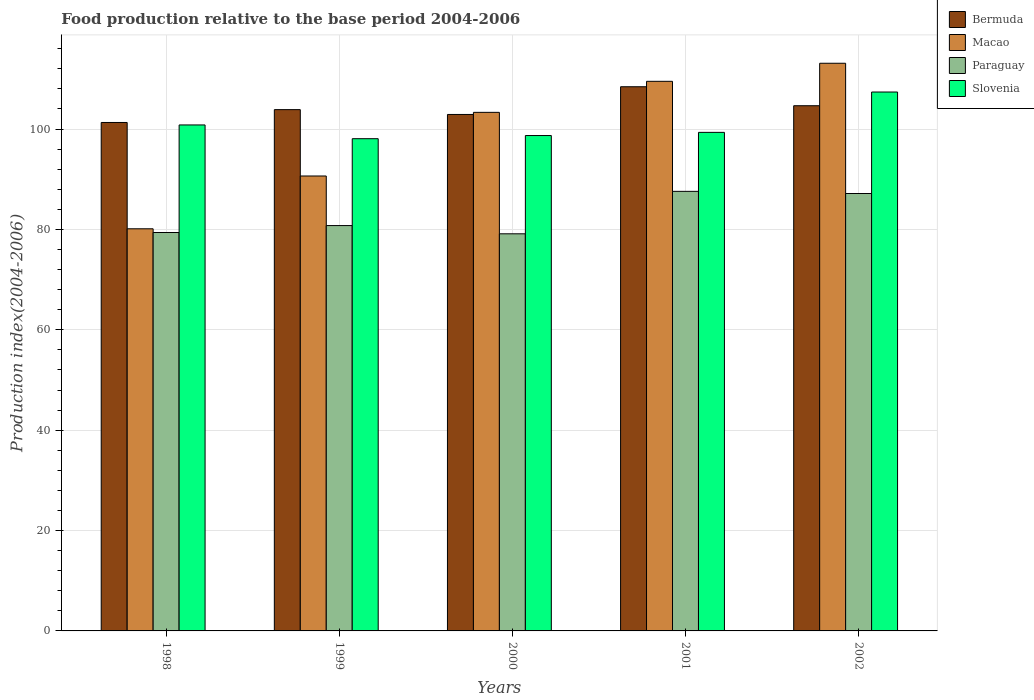How many groups of bars are there?
Offer a terse response. 5. How many bars are there on the 1st tick from the left?
Provide a short and direct response. 4. How many bars are there on the 2nd tick from the right?
Offer a very short reply. 4. What is the label of the 4th group of bars from the left?
Your answer should be very brief. 2001. In how many cases, is the number of bars for a given year not equal to the number of legend labels?
Give a very brief answer. 0. What is the food production index in Paraguay in 1998?
Offer a very short reply. 79.38. Across all years, what is the maximum food production index in Macao?
Your answer should be very brief. 113.1. Across all years, what is the minimum food production index in Bermuda?
Your answer should be compact. 101.3. What is the total food production index in Slovenia in the graph?
Provide a short and direct response. 504.28. What is the difference between the food production index in Macao in 1999 and that in 2000?
Your answer should be very brief. -12.68. What is the difference between the food production index in Slovenia in 2000 and the food production index in Macao in 1999?
Provide a succinct answer. 8.06. What is the average food production index in Paraguay per year?
Offer a very short reply. 82.8. In the year 2000, what is the difference between the food production index in Macao and food production index in Bermuda?
Keep it short and to the point. 0.42. What is the ratio of the food production index in Paraguay in 1998 to that in 2001?
Make the answer very short. 0.91. Is the difference between the food production index in Macao in 1999 and 2001 greater than the difference between the food production index in Bermuda in 1999 and 2001?
Offer a very short reply. No. What is the difference between the highest and the second highest food production index in Paraguay?
Provide a short and direct response. 0.43. What is the difference between the highest and the lowest food production index in Macao?
Your answer should be very brief. 32.98. Is the sum of the food production index in Bermuda in 1998 and 2002 greater than the maximum food production index in Paraguay across all years?
Keep it short and to the point. Yes. Is it the case that in every year, the sum of the food production index in Bermuda and food production index in Paraguay is greater than the sum of food production index in Macao and food production index in Slovenia?
Your answer should be very brief. No. What does the 2nd bar from the left in 2001 represents?
Provide a short and direct response. Macao. What does the 4th bar from the right in 1998 represents?
Provide a succinct answer. Bermuda. Is it the case that in every year, the sum of the food production index in Paraguay and food production index in Bermuda is greater than the food production index in Slovenia?
Make the answer very short. Yes. Are all the bars in the graph horizontal?
Offer a terse response. No. What is the difference between two consecutive major ticks on the Y-axis?
Your answer should be very brief. 20. How many legend labels are there?
Give a very brief answer. 4. What is the title of the graph?
Keep it short and to the point. Food production relative to the base period 2004-2006. What is the label or title of the X-axis?
Keep it short and to the point. Years. What is the label or title of the Y-axis?
Your response must be concise. Production index(2004-2006). What is the Production index(2004-2006) of Bermuda in 1998?
Offer a very short reply. 101.3. What is the Production index(2004-2006) of Macao in 1998?
Make the answer very short. 80.12. What is the Production index(2004-2006) of Paraguay in 1998?
Provide a succinct answer. 79.38. What is the Production index(2004-2006) in Slovenia in 1998?
Give a very brief answer. 100.81. What is the Production index(2004-2006) of Bermuda in 1999?
Provide a succinct answer. 103.86. What is the Production index(2004-2006) of Macao in 1999?
Your response must be concise. 90.64. What is the Production index(2004-2006) in Paraguay in 1999?
Provide a short and direct response. 80.76. What is the Production index(2004-2006) in Slovenia in 1999?
Provide a succinct answer. 98.07. What is the Production index(2004-2006) in Bermuda in 2000?
Keep it short and to the point. 102.9. What is the Production index(2004-2006) in Macao in 2000?
Your answer should be compact. 103.32. What is the Production index(2004-2006) in Paraguay in 2000?
Offer a terse response. 79.12. What is the Production index(2004-2006) of Slovenia in 2000?
Ensure brevity in your answer.  98.7. What is the Production index(2004-2006) of Bermuda in 2001?
Your answer should be very brief. 108.42. What is the Production index(2004-2006) in Macao in 2001?
Keep it short and to the point. 109.5. What is the Production index(2004-2006) of Paraguay in 2001?
Keep it short and to the point. 87.58. What is the Production index(2004-2006) in Slovenia in 2001?
Ensure brevity in your answer.  99.33. What is the Production index(2004-2006) in Bermuda in 2002?
Offer a terse response. 104.64. What is the Production index(2004-2006) in Macao in 2002?
Provide a short and direct response. 113.1. What is the Production index(2004-2006) in Paraguay in 2002?
Keep it short and to the point. 87.15. What is the Production index(2004-2006) in Slovenia in 2002?
Offer a very short reply. 107.37. Across all years, what is the maximum Production index(2004-2006) of Bermuda?
Make the answer very short. 108.42. Across all years, what is the maximum Production index(2004-2006) of Macao?
Your response must be concise. 113.1. Across all years, what is the maximum Production index(2004-2006) in Paraguay?
Ensure brevity in your answer.  87.58. Across all years, what is the maximum Production index(2004-2006) in Slovenia?
Your response must be concise. 107.37. Across all years, what is the minimum Production index(2004-2006) in Bermuda?
Ensure brevity in your answer.  101.3. Across all years, what is the minimum Production index(2004-2006) in Macao?
Offer a very short reply. 80.12. Across all years, what is the minimum Production index(2004-2006) of Paraguay?
Offer a very short reply. 79.12. Across all years, what is the minimum Production index(2004-2006) of Slovenia?
Offer a terse response. 98.07. What is the total Production index(2004-2006) of Bermuda in the graph?
Provide a succinct answer. 521.12. What is the total Production index(2004-2006) of Macao in the graph?
Offer a very short reply. 496.68. What is the total Production index(2004-2006) in Paraguay in the graph?
Give a very brief answer. 413.99. What is the total Production index(2004-2006) of Slovenia in the graph?
Give a very brief answer. 504.28. What is the difference between the Production index(2004-2006) of Bermuda in 1998 and that in 1999?
Your response must be concise. -2.56. What is the difference between the Production index(2004-2006) in Macao in 1998 and that in 1999?
Your response must be concise. -10.52. What is the difference between the Production index(2004-2006) in Paraguay in 1998 and that in 1999?
Keep it short and to the point. -1.38. What is the difference between the Production index(2004-2006) in Slovenia in 1998 and that in 1999?
Keep it short and to the point. 2.74. What is the difference between the Production index(2004-2006) of Macao in 1998 and that in 2000?
Keep it short and to the point. -23.2. What is the difference between the Production index(2004-2006) of Paraguay in 1998 and that in 2000?
Your answer should be very brief. 0.26. What is the difference between the Production index(2004-2006) in Slovenia in 1998 and that in 2000?
Your answer should be compact. 2.11. What is the difference between the Production index(2004-2006) of Bermuda in 1998 and that in 2001?
Make the answer very short. -7.12. What is the difference between the Production index(2004-2006) in Macao in 1998 and that in 2001?
Your answer should be very brief. -29.38. What is the difference between the Production index(2004-2006) in Slovenia in 1998 and that in 2001?
Keep it short and to the point. 1.48. What is the difference between the Production index(2004-2006) in Bermuda in 1998 and that in 2002?
Make the answer very short. -3.34. What is the difference between the Production index(2004-2006) of Macao in 1998 and that in 2002?
Provide a short and direct response. -32.98. What is the difference between the Production index(2004-2006) in Paraguay in 1998 and that in 2002?
Your response must be concise. -7.77. What is the difference between the Production index(2004-2006) of Slovenia in 1998 and that in 2002?
Provide a short and direct response. -6.56. What is the difference between the Production index(2004-2006) in Macao in 1999 and that in 2000?
Your answer should be compact. -12.68. What is the difference between the Production index(2004-2006) of Paraguay in 1999 and that in 2000?
Provide a succinct answer. 1.64. What is the difference between the Production index(2004-2006) of Slovenia in 1999 and that in 2000?
Ensure brevity in your answer.  -0.63. What is the difference between the Production index(2004-2006) of Bermuda in 1999 and that in 2001?
Provide a succinct answer. -4.56. What is the difference between the Production index(2004-2006) of Macao in 1999 and that in 2001?
Provide a short and direct response. -18.86. What is the difference between the Production index(2004-2006) of Paraguay in 1999 and that in 2001?
Give a very brief answer. -6.82. What is the difference between the Production index(2004-2006) in Slovenia in 1999 and that in 2001?
Offer a terse response. -1.26. What is the difference between the Production index(2004-2006) of Bermuda in 1999 and that in 2002?
Your response must be concise. -0.78. What is the difference between the Production index(2004-2006) of Macao in 1999 and that in 2002?
Provide a short and direct response. -22.46. What is the difference between the Production index(2004-2006) of Paraguay in 1999 and that in 2002?
Offer a terse response. -6.39. What is the difference between the Production index(2004-2006) of Bermuda in 2000 and that in 2001?
Keep it short and to the point. -5.52. What is the difference between the Production index(2004-2006) of Macao in 2000 and that in 2001?
Your answer should be very brief. -6.18. What is the difference between the Production index(2004-2006) of Paraguay in 2000 and that in 2001?
Make the answer very short. -8.46. What is the difference between the Production index(2004-2006) in Slovenia in 2000 and that in 2001?
Offer a very short reply. -0.63. What is the difference between the Production index(2004-2006) of Bermuda in 2000 and that in 2002?
Provide a succinct answer. -1.74. What is the difference between the Production index(2004-2006) of Macao in 2000 and that in 2002?
Your answer should be compact. -9.78. What is the difference between the Production index(2004-2006) of Paraguay in 2000 and that in 2002?
Make the answer very short. -8.03. What is the difference between the Production index(2004-2006) in Slovenia in 2000 and that in 2002?
Offer a very short reply. -8.67. What is the difference between the Production index(2004-2006) in Bermuda in 2001 and that in 2002?
Make the answer very short. 3.78. What is the difference between the Production index(2004-2006) in Macao in 2001 and that in 2002?
Keep it short and to the point. -3.6. What is the difference between the Production index(2004-2006) of Paraguay in 2001 and that in 2002?
Ensure brevity in your answer.  0.43. What is the difference between the Production index(2004-2006) of Slovenia in 2001 and that in 2002?
Provide a short and direct response. -8.04. What is the difference between the Production index(2004-2006) in Bermuda in 1998 and the Production index(2004-2006) in Macao in 1999?
Offer a very short reply. 10.66. What is the difference between the Production index(2004-2006) in Bermuda in 1998 and the Production index(2004-2006) in Paraguay in 1999?
Give a very brief answer. 20.54. What is the difference between the Production index(2004-2006) in Bermuda in 1998 and the Production index(2004-2006) in Slovenia in 1999?
Keep it short and to the point. 3.23. What is the difference between the Production index(2004-2006) of Macao in 1998 and the Production index(2004-2006) of Paraguay in 1999?
Offer a terse response. -0.64. What is the difference between the Production index(2004-2006) in Macao in 1998 and the Production index(2004-2006) in Slovenia in 1999?
Make the answer very short. -17.95. What is the difference between the Production index(2004-2006) in Paraguay in 1998 and the Production index(2004-2006) in Slovenia in 1999?
Provide a succinct answer. -18.69. What is the difference between the Production index(2004-2006) of Bermuda in 1998 and the Production index(2004-2006) of Macao in 2000?
Ensure brevity in your answer.  -2.02. What is the difference between the Production index(2004-2006) of Bermuda in 1998 and the Production index(2004-2006) of Paraguay in 2000?
Offer a very short reply. 22.18. What is the difference between the Production index(2004-2006) in Bermuda in 1998 and the Production index(2004-2006) in Slovenia in 2000?
Provide a succinct answer. 2.6. What is the difference between the Production index(2004-2006) of Macao in 1998 and the Production index(2004-2006) of Paraguay in 2000?
Offer a terse response. 1. What is the difference between the Production index(2004-2006) in Macao in 1998 and the Production index(2004-2006) in Slovenia in 2000?
Give a very brief answer. -18.58. What is the difference between the Production index(2004-2006) in Paraguay in 1998 and the Production index(2004-2006) in Slovenia in 2000?
Give a very brief answer. -19.32. What is the difference between the Production index(2004-2006) of Bermuda in 1998 and the Production index(2004-2006) of Paraguay in 2001?
Your response must be concise. 13.72. What is the difference between the Production index(2004-2006) in Bermuda in 1998 and the Production index(2004-2006) in Slovenia in 2001?
Give a very brief answer. 1.97. What is the difference between the Production index(2004-2006) of Macao in 1998 and the Production index(2004-2006) of Paraguay in 2001?
Ensure brevity in your answer.  -7.46. What is the difference between the Production index(2004-2006) in Macao in 1998 and the Production index(2004-2006) in Slovenia in 2001?
Provide a short and direct response. -19.21. What is the difference between the Production index(2004-2006) of Paraguay in 1998 and the Production index(2004-2006) of Slovenia in 2001?
Offer a terse response. -19.95. What is the difference between the Production index(2004-2006) of Bermuda in 1998 and the Production index(2004-2006) of Paraguay in 2002?
Make the answer very short. 14.15. What is the difference between the Production index(2004-2006) of Bermuda in 1998 and the Production index(2004-2006) of Slovenia in 2002?
Your answer should be very brief. -6.07. What is the difference between the Production index(2004-2006) of Macao in 1998 and the Production index(2004-2006) of Paraguay in 2002?
Your answer should be very brief. -7.03. What is the difference between the Production index(2004-2006) in Macao in 1998 and the Production index(2004-2006) in Slovenia in 2002?
Offer a terse response. -27.25. What is the difference between the Production index(2004-2006) in Paraguay in 1998 and the Production index(2004-2006) in Slovenia in 2002?
Provide a succinct answer. -27.99. What is the difference between the Production index(2004-2006) in Bermuda in 1999 and the Production index(2004-2006) in Macao in 2000?
Offer a very short reply. 0.54. What is the difference between the Production index(2004-2006) of Bermuda in 1999 and the Production index(2004-2006) of Paraguay in 2000?
Your response must be concise. 24.74. What is the difference between the Production index(2004-2006) in Bermuda in 1999 and the Production index(2004-2006) in Slovenia in 2000?
Provide a succinct answer. 5.16. What is the difference between the Production index(2004-2006) of Macao in 1999 and the Production index(2004-2006) of Paraguay in 2000?
Keep it short and to the point. 11.52. What is the difference between the Production index(2004-2006) in Macao in 1999 and the Production index(2004-2006) in Slovenia in 2000?
Provide a succinct answer. -8.06. What is the difference between the Production index(2004-2006) in Paraguay in 1999 and the Production index(2004-2006) in Slovenia in 2000?
Make the answer very short. -17.94. What is the difference between the Production index(2004-2006) in Bermuda in 1999 and the Production index(2004-2006) in Macao in 2001?
Keep it short and to the point. -5.64. What is the difference between the Production index(2004-2006) of Bermuda in 1999 and the Production index(2004-2006) of Paraguay in 2001?
Provide a succinct answer. 16.28. What is the difference between the Production index(2004-2006) of Bermuda in 1999 and the Production index(2004-2006) of Slovenia in 2001?
Your response must be concise. 4.53. What is the difference between the Production index(2004-2006) of Macao in 1999 and the Production index(2004-2006) of Paraguay in 2001?
Provide a short and direct response. 3.06. What is the difference between the Production index(2004-2006) of Macao in 1999 and the Production index(2004-2006) of Slovenia in 2001?
Offer a very short reply. -8.69. What is the difference between the Production index(2004-2006) of Paraguay in 1999 and the Production index(2004-2006) of Slovenia in 2001?
Your answer should be compact. -18.57. What is the difference between the Production index(2004-2006) in Bermuda in 1999 and the Production index(2004-2006) in Macao in 2002?
Ensure brevity in your answer.  -9.24. What is the difference between the Production index(2004-2006) of Bermuda in 1999 and the Production index(2004-2006) of Paraguay in 2002?
Offer a terse response. 16.71. What is the difference between the Production index(2004-2006) of Bermuda in 1999 and the Production index(2004-2006) of Slovenia in 2002?
Your answer should be compact. -3.51. What is the difference between the Production index(2004-2006) in Macao in 1999 and the Production index(2004-2006) in Paraguay in 2002?
Keep it short and to the point. 3.49. What is the difference between the Production index(2004-2006) of Macao in 1999 and the Production index(2004-2006) of Slovenia in 2002?
Ensure brevity in your answer.  -16.73. What is the difference between the Production index(2004-2006) of Paraguay in 1999 and the Production index(2004-2006) of Slovenia in 2002?
Your response must be concise. -26.61. What is the difference between the Production index(2004-2006) in Bermuda in 2000 and the Production index(2004-2006) in Macao in 2001?
Provide a succinct answer. -6.6. What is the difference between the Production index(2004-2006) in Bermuda in 2000 and the Production index(2004-2006) in Paraguay in 2001?
Your answer should be compact. 15.32. What is the difference between the Production index(2004-2006) of Bermuda in 2000 and the Production index(2004-2006) of Slovenia in 2001?
Make the answer very short. 3.57. What is the difference between the Production index(2004-2006) in Macao in 2000 and the Production index(2004-2006) in Paraguay in 2001?
Your answer should be compact. 15.74. What is the difference between the Production index(2004-2006) in Macao in 2000 and the Production index(2004-2006) in Slovenia in 2001?
Your answer should be compact. 3.99. What is the difference between the Production index(2004-2006) of Paraguay in 2000 and the Production index(2004-2006) of Slovenia in 2001?
Provide a short and direct response. -20.21. What is the difference between the Production index(2004-2006) in Bermuda in 2000 and the Production index(2004-2006) in Macao in 2002?
Provide a short and direct response. -10.2. What is the difference between the Production index(2004-2006) in Bermuda in 2000 and the Production index(2004-2006) in Paraguay in 2002?
Your answer should be very brief. 15.75. What is the difference between the Production index(2004-2006) in Bermuda in 2000 and the Production index(2004-2006) in Slovenia in 2002?
Your answer should be very brief. -4.47. What is the difference between the Production index(2004-2006) of Macao in 2000 and the Production index(2004-2006) of Paraguay in 2002?
Your answer should be very brief. 16.17. What is the difference between the Production index(2004-2006) of Macao in 2000 and the Production index(2004-2006) of Slovenia in 2002?
Your answer should be compact. -4.05. What is the difference between the Production index(2004-2006) in Paraguay in 2000 and the Production index(2004-2006) in Slovenia in 2002?
Your answer should be very brief. -28.25. What is the difference between the Production index(2004-2006) in Bermuda in 2001 and the Production index(2004-2006) in Macao in 2002?
Your answer should be very brief. -4.68. What is the difference between the Production index(2004-2006) in Bermuda in 2001 and the Production index(2004-2006) in Paraguay in 2002?
Your answer should be very brief. 21.27. What is the difference between the Production index(2004-2006) in Macao in 2001 and the Production index(2004-2006) in Paraguay in 2002?
Make the answer very short. 22.35. What is the difference between the Production index(2004-2006) in Macao in 2001 and the Production index(2004-2006) in Slovenia in 2002?
Provide a short and direct response. 2.13. What is the difference between the Production index(2004-2006) of Paraguay in 2001 and the Production index(2004-2006) of Slovenia in 2002?
Keep it short and to the point. -19.79. What is the average Production index(2004-2006) in Bermuda per year?
Your answer should be compact. 104.22. What is the average Production index(2004-2006) of Macao per year?
Offer a terse response. 99.34. What is the average Production index(2004-2006) in Paraguay per year?
Your answer should be compact. 82.8. What is the average Production index(2004-2006) in Slovenia per year?
Offer a terse response. 100.86. In the year 1998, what is the difference between the Production index(2004-2006) in Bermuda and Production index(2004-2006) in Macao?
Offer a very short reply. 21.18. In the year 1998, what is the difference between the Production index(2004-2006) in Bermuda and Production index(2004-2006) in Paraguay?
Your response must be concise. 21.92. In the year 1998, what is the difference between the Production index(2004-2006) of Bermuda and Production index(2004-2006) of Slovenia?
Provide a succinct answer. 0.49. In the year 1998, what is the difference between the Production index(2004-2006) of Macao and Production index(2004-2006) of Paraguay?
Keep it short and to the point. 0.74. In the year 1998, what is the difference between the Production index(2004-2006) in Macao and Production index(2004-2006) in Slovenia?
Your answer should be compact. -20.69. In the year 1998, what is the difference between the Production index(2004-2006) of Paraguay and Production index(2004-2006) of Slovenia?
Offer a terse response. -21.43. In the year 1999, what is the difference between the Production index(2004-2006) in Bermuda and Production index(2004-2006) in Macao?
Your response must be concise. 13.22. In the year 1999, what is the difference between the Production index(2004-2006) of Bermuda and Production index(2004-2006) of Paraguay?
Provide a short and direct response. 23.1. In the year 1999, what is the difference between the Production index(2004-2006) in Bermuda and Production index(2004-2006) in Slovenia?
Offer a terse response. 5.79. In the year 1999, what is the difference between the Production index(2004-2006) of Macao and Production index(2004-2006) of Paraguay?
Make the answer very short. 9.88. In the year 1999, what is the difference between the Production index(2004-2006) of Macao and Production index(2004-2006) of Slovenia?
Provide a short and direct response. -7.43. In the year 1999, what is the difference between the Production index(2004-2006) of Paraguay and Production index(2004-2006) of Slovenia?
Provide a succinct answer. -17.31. In the year 2000, what is the difference between the Production index(2004-2006) in Bermuda and Production index(2004-2006) in Macao?
Give a very brief answer. -0.42. In the year 2000, what is the difference between the Production index(2004-2006) in Bermuda and Production index(2004-2006) in Paraguay?
Your response must be concise. 23.78. In the year 2000, what is the difference between the Production index(2004-2006) of Macao and Production index(2004-2006) of Paraguay?
Your answer should be very brief. 24.2. In the year 2000, what is the difference between the Production index(2004-2006) in Macao and Production index(2004-2006) in Slovenia?
Your answer should be very brief. 4.62. In the year 2000, what is the difference between the Production index(2004-2006) of Paraguay and Production index(2004-2006) of Slovenia?
Provide a succinct answer. -19.58. In the year 2001, what is the difference between the Production index(2004-2006) of Bermuda and Production index(2004-2006) of Macao?
Your answer should be very brief. -1.08. In the year 2001, what is the difference between the Production index(2004-2006) of Bermuda and Production index(2004-2006) of Paraguay?
Provide a succinct answer. 20.84. In the year 2001, what is the difference between the Production index(2004-2006) in Bermuda and Production index(2004-2006) in Slovenia?
Provide a short and direct response. 9.09. In the year 2001, what is the difference between the Production index(2004-2006) in Macao and Production index(2004-2006) in Paraguay?
Your answer should be very brief. 21.92. In the year 2001, what is the difference between the Production index(2004-2006) in Macao and Production index(2004-2006) in Slovenia?
Offer a terse response. 10.17. In the year 2001, what is the difference between the Production index(2004-2006) in Paraguay and Production index(2004-2006) in Slovenia?
Offer a very short reply. -11.75. In the year 2002, what is the difference between the Production index(2004-2006) in Bermuda and Production index(2004-2006) in Macao?
Your response must be concise. -8.46. In the year 2002, what is the difference between the Production index(2004-2006) in Bermuda and Production index(2004-2006) in Paraguay?
Keep it short and to the point. 17.49. In the year 2002, what is the difference between the Production index(2004-2006) of Bermuda and Production index(2004-2006) of Slovenia?
Give a very brief answer. -2.73. In the year 2002, what is the difference between the Production index(2004-2006) in Macao and Production index(2004-2006) in Paraguay?
Give a very brief answer. 25.95. In the year 2002, what is the difference between the Production index(2004-2006) of Macao and Production index(2004-2006) of Slovenia?
Make the answer very short. 5.73. In the year 2002, what is the difference between the Production index(2004-2006) of Paraguay and Production index(2004-2006) of Slovenia?
Keep it short and to the point. -20.22. What is the ratio of the Production index(2004-2006) of Bermuda in 1998 to that in 1999?
Offer a very short reply. 0.98. What is the ratio of the Production index(2004-2006) in Macao in 1998 to that in 1999?
Your answer should be compact. 0.88. What is the ratio of the Production index(2004-2006) in Paraguay in 1998 to that in 1999?
Your response must be concise. 0.98. What is the ratio of the Production index(2004-2006) in Slovenia in 1998 to that in 1999?
Your response must be concise. 1.03. What is the ratio of the Production index(2004-2006) in Bermuda in 1998 to that in 2000?
Offer a very short reply. 0.98. What is the ratio of the Production index(2004-2006) of Macao in 1998 to that in 2000?
Keep it short and to the point. 0.78. What is the ratio of the Production index(2004-2006) in Slovenia in 1998 to that in 2000?
Provide a succinct answer. 1.02. What is the ratio of the Production index(2004-2006) in Bermuda in 1998 to that in 2001?
Make the answer very short. 0.93. What is the ratio of the Production index(2004-2006) of Macao in 1998 to that in 2001?
Provide a short and direct response. 0.73. What is the ratio of the Production index(2004-2006) in Paraguay in 1998 to that in 2001?
Ensure brevity in your answer.  0.91. What is the ratio of the Production index(2004-2006) of Slovenia in 1998 to that in 2001?
Your answer should be compact. 1.01. What is the ratio of the Production index(2004-2006) of Bermuda in 1998 to that in 2002?
Ensure brevity in your answer.  0.97. What is the ratio of the Production index(2004-2006) of Macao in 1998 to that in 2002?
Make the answer very short. 0.71. What is the ratio of the Production index(2004-2006) in Paraguay in 1998 to that in 2002?
Your answer should be very brief. 0.91. What is the ratio of the Production index(2004-2006) of Slovenia in 1998 to that in 2002?
Keep it short and to the point. 0.94. What is the ratio of the Production index(2004-2006) in Bermuda in 1999 to that in 2000?
Your answer should be very brief. 1.01. What is the ratio of the Production index(2004-2006) in Macao in 1999 to that in 2000?
Your response must be concise. 0.88. What is the ratio of the Production index(2004-2006) of Paraguay in 1999 to that in 2000?
Your answer should be compact. 1.02. What is the ratio of the Production index(2004-2006) of Bermuda in 1999 to that in 2001?
Make the answer very short. 0.96. What is the ratio of the Production index(2004-2006) in Macao in 1999 to that in 2001?
Provide a succinct answer. 0.83. What is the ratio of the Production index(2004-2006) in Paraguay in 1999 to that in 2001?
Offer a very short reply. 0.92. What is the ratio of the Production index(2004-2006) of Slovenia in 1999 to that in 2001?
Your answer should be compact. 0.99. What is the ratio of the Production index(2004-2006) in Macao in 1999 to that in 2002?
Keep it short and to the point. 0.8. What is the ratio of the Production index(2004-2006) of Paraguay in 1999 to that in 2002?
Ensure brevity in your answer.  0.93. What is the ratio of the Production index(2004-2006) in Slovenia in 1999 to that in 2002?
Your answer should be compact. 0.91. What is the ratio of the Production index(2004-2006) in Bermuda in 2000 to that in 2001?
Make the answer very short. 0.95. What is the ratio of the Production index(2004-2006) in Macao in 2000 to that in 2001?
Provide a succinct answer. 0.94. What is the ratio of the Production index(2004-2006) in Paraguay in 2000 to that in 2001?
Make the answer very short. 0.9. What is the ratio of the Production index(2004-2006) of Slovenia in 2000 to that in 2001?
Your answer should be very brief. 0.99. What is the ratio of the Production index(2004-2006) in Bermuda in 2000 to that in 2002?
Make the answer very short. 0.98. What is the ratio of the Production index(2004-2006) in Macao in 2000 to that in 2002?
Your answer should be compact. 0.91. What is the ratio of the Production index(2004-2006) in Paraguay in 2000 to that in 2002?
Your response must be concise. 0.91. What is the ratio of the Production index(2004-2006) in Slovenia in 2000 to that in 2002?
Provide a succinct answer. 0.92. What is the ratio of the Production index(2004-2006) of Bermuda in 2001 to that in 2002?
Give a very brief answer. 1.04. What is the ratio of the Production index(2004-2006) in Macao in 2001 to that in 2002?
Make the answer very short. 0.97. What is the ratio of the Production index(2004-2006) in Paraguay in 2001 to that in 2002?
Give a very brief answer. 1. What is the ratio of the Production index(2004-2006) in Slovenia in 2001 to that in 2002?
Your response must be concise. 0.93. What is the difference between the highest and the second highest Production index(2004-2006) of Bermuda?
Your answer should be compact. 3.78. What is the difference between the highest and the second highest Production index(2004-2006) in Macao?
Provide a succinct answer. 3.6. What is the difference between the highest and the second highest Production index(2004-2006) of Paraguay?
Make the answer very short. 0.43. What is the difference between the highest and the second highest Production index(2004-2006) in Slovenia?
Offer a very short reply. 6.56. What is the difference between the highest and the lowest Production index(2004-2006) of Bermuda?
Offer a very short reply. 7.12. What is the difference between the highest and the lowest Production index(2004-2006) of Macao?
Provide a succinct answer. 32.98. What is the difference between the highest and the lowest Production index(2004-2006) in Paraguay?
Your response must be concise. 8.46. What is the difference between the highest and the lowest Production index(2004-2006) in Slovenia?
Ensure brevity in your answer.  9.3. 